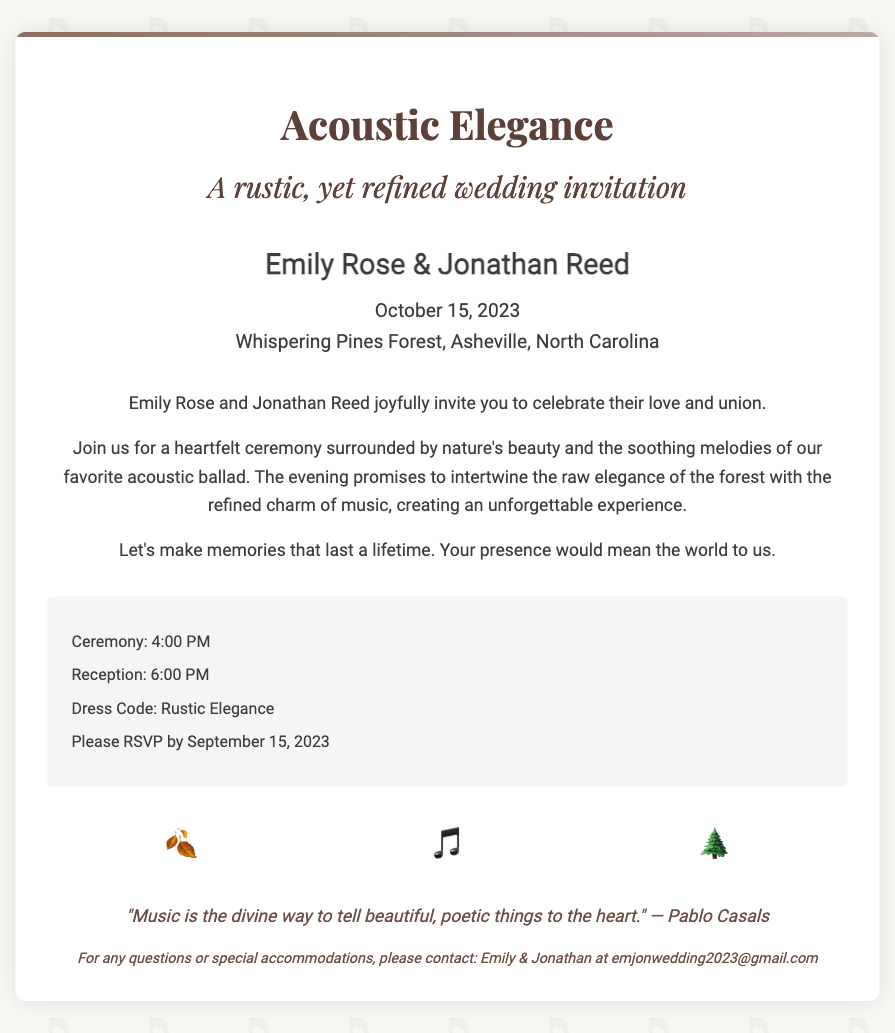What is the couple's first names? The couple's names are explicitly mentioned in the invitation.
Answer: Emily Rose & Jonathan Reed When is the wedding ceremony taking place? The date of the ceremony is provided in the document.
Answer: October 15, 2023 What location will the wedding be held? The document specifies the venue for the ceremony.
Answer: Whispering Pines Forest, Asheville, North Carolina What time does the reception start? The start time for the reception is listed in the event details.
Answer: 6:00 PM What is the dress code mentioned in the invitation? The document specifies the preferred attire for guests.
Answer: Rustic Elegance What is the RSVP deadline? The deadline for RSVPs is stated in the event details.
Answer: September 15, 2023 What theme is highlighted in the wedding invitation? The theme is expressed in the title and subtitle of the invitation.
Answer: Acoustic Elegance Which quote is included in the footer of the invitation? The footer contains a quote attributed to a well-known figure about music.
Answer: "Music is the divine way to tell beautiful, poetic things to the heart." — Pablo Casals What graphic elements are included in the design section? The design elements incorporated nature and music themes.
Answer: 🍂 🎵 🌲 